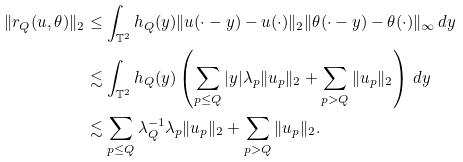<formula> <loc_0><loc_0><loc_500><loc_500>\| r _ { Q } ( u , \theta ) \| _ { 2 } & \leq \int _ { \mathbb { T } ^ { 2 } } h _ { Q } ( y ) \| u ( \cdot - y ) - u ( \cdot ) \| _ { 2 } \| \theta ( \cdot - y ) - \theta ( \cdot ) \| _ { \infty } \, d y \\ & \lesssim \int _ { \mathbb { T } ^ { 2 } } h _ { Q } ( y ) \left ( \sum _ { p \leq Q } | y | \lambda _ { p } \| u _ { p } \| _ { 2 } + \sum _ { p > Q } \| u _ { p } \| _ { 2 } \right ) \, d y \\ & \lesssim \sum _ { p \leq Q } \lambda _ { Q } ^ { - 1 } \lambda _ { p } \| u _ { p } \| _ { 2 } + \sum _ { p > Q } \| u _ { p } \| _ { 2 } .</formula> 